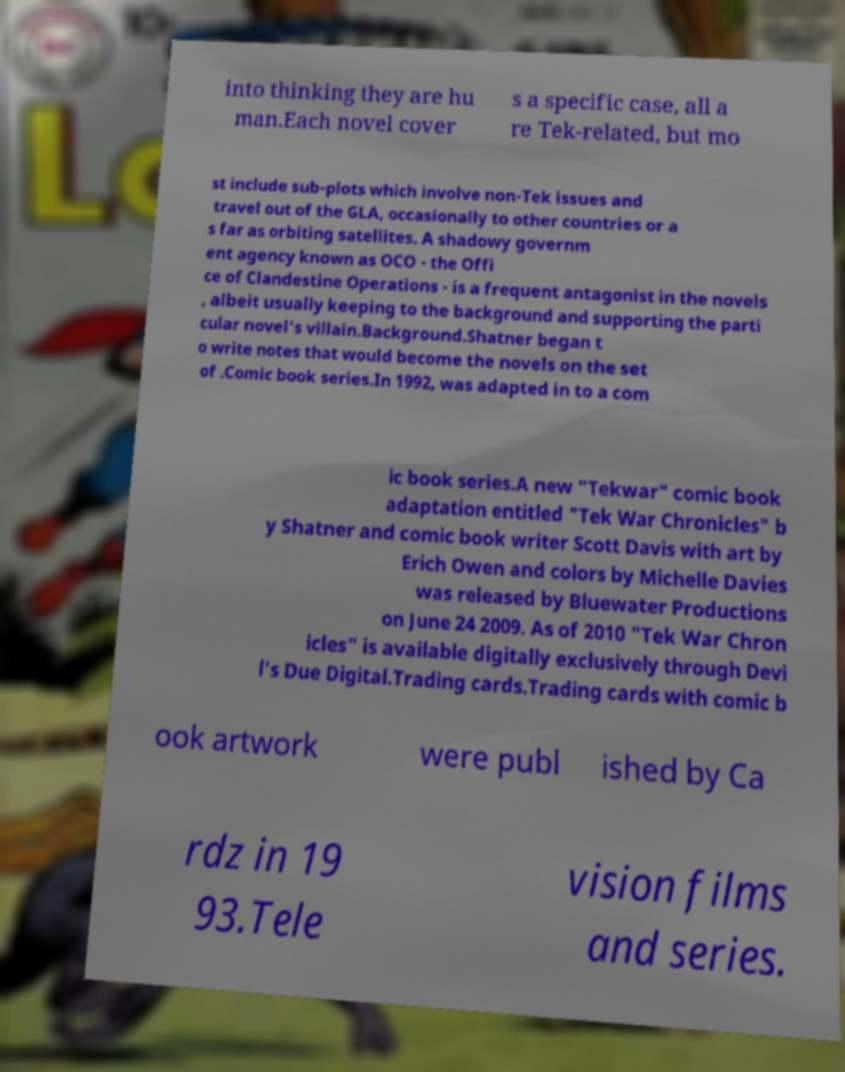I need the written content from this picture converted into text. Can you do that? into thinking they are hu man.Each novel cover s a specific case, all a re Tek-related, but mo st include sub-plots which involve non-Tek issues and travel out of the GLA, occasionally to other countries or a s far as orbiting satellites. A shadowy governm ent agency known as OCO - the Offi ce of Clandestine Operations - is a frequent antagonist in the novels , albeit usually keeping to the background and supporting the parti cular novel's villain.Background.Shatner began t o write notes that would become the novels on the set of .Comic book series.In 1992, was adapted in to a com ic book series.A new "Tekwar" comic book adaptation entitled "Tek War Chronicles" b y Shatner and comic book writer Scott Davis with art by Erich Owen and colors by Michelle Davies was released by Bluewater Productions on June 24 2009. As of 2010 "Tek War Chron icles" is available digitally exclusively through Devi l's Due Digital.Trading cards.Trading cards with comic b ook artwork were publ ished by Ca rdz in 19 93.Tele vision films and series. 